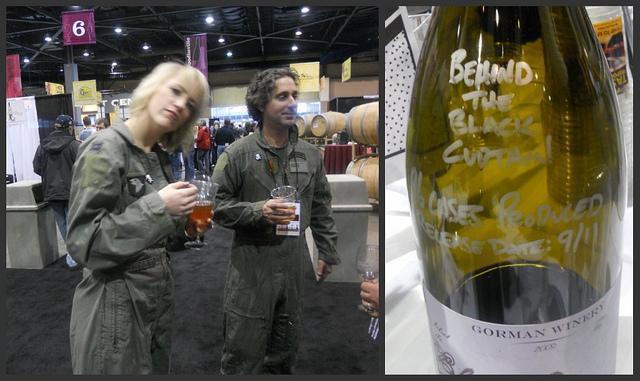How many people are in the photo?
Give a very brief answer. 3. 